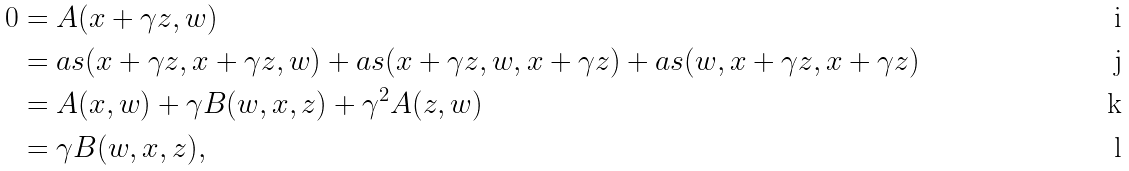Convert formula to latex. <formula><loc_0><loc_0><loc_500><loc_500>0 & = A ( x + \gamma z , w ) \\ & = a s ( x + \gamma z , x + \gamma z , w ) + a s ( x + \gamma z , w , x + \gamma z ) + a s ( w , x + \gamma z , x + \gamma z ) \\ & = A ( x , w ) + \gamma B ( w , x , z ) + \gamma ^ { 2 } A ( z , w ) \\ & = \gamma B ( w , x , z ) ,</formula> 